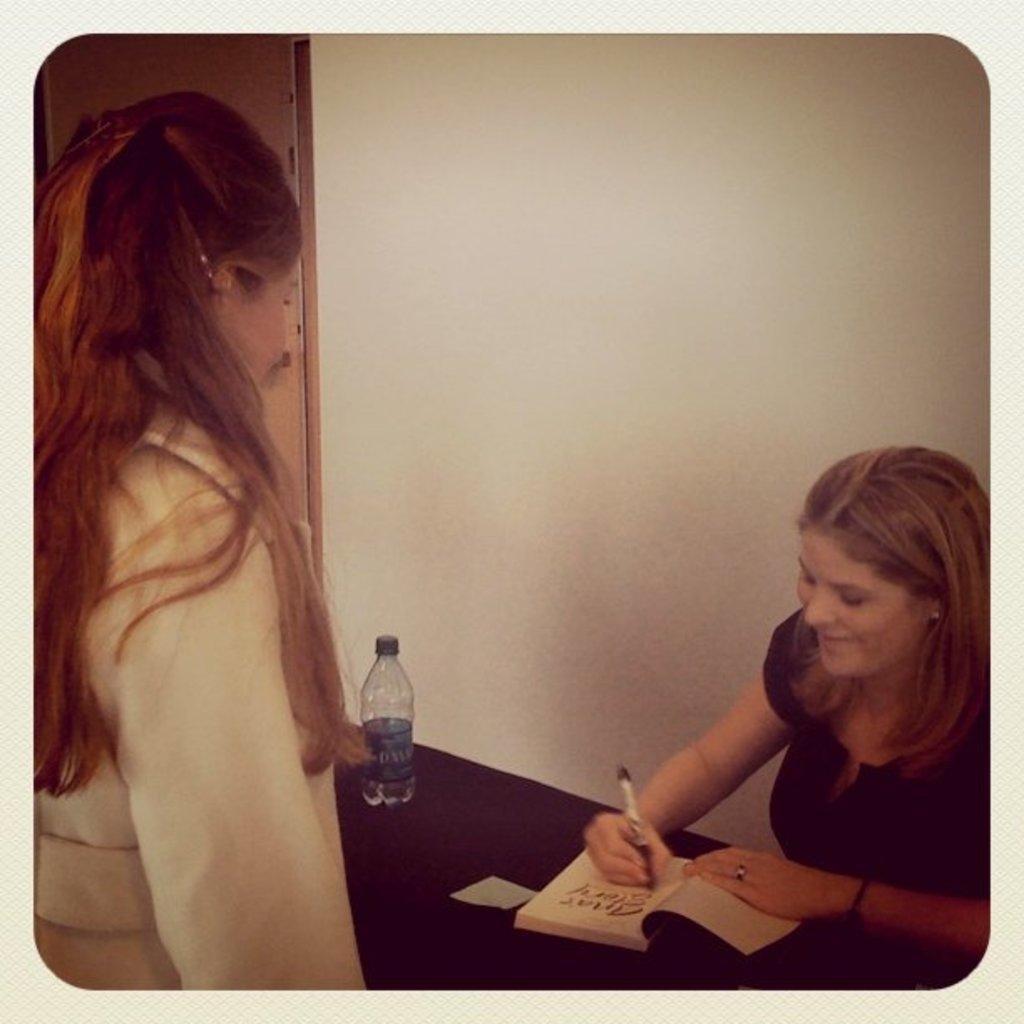Can you describe this image briefly? This image is taken indoors. In the background there is a wall and there is a door. At the bottom of the image there is a table with a water bottle and a book on it. On the left side of the image a girl is standing. On the right side of the image a woman is sitting and she is writing with a pen on the book. 